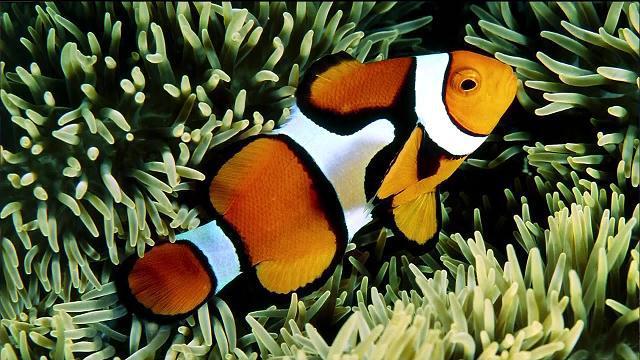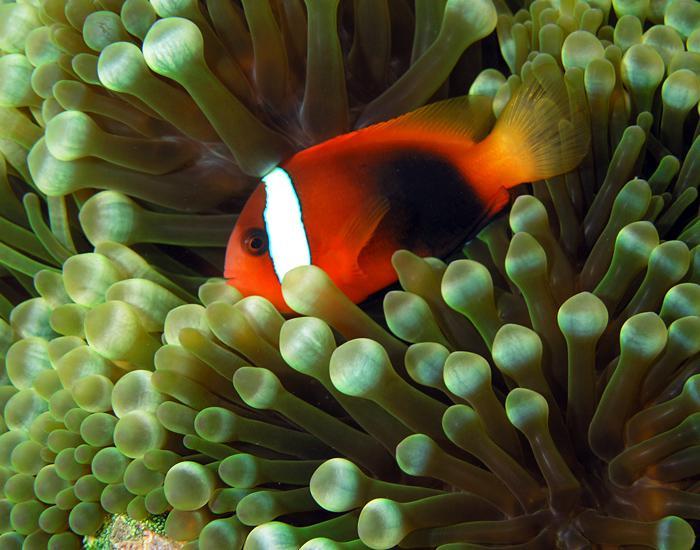The first image is the image on the left, the second image is the image on the right. Examine the images to the left and right. Is the description "There are two fish" accurate? Answer yes or no. Yes. 